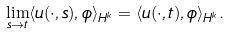Convert formula to latex. <formula><loc_0><loc_0><loc_500><loc_500>\lim _ { s \rightarrow t } \langle u ( \cdot , s ) , \phi \rangle _ { H ^ { k } } = \langle u ( \cdot , t ) , \phi \rangle _ { H ^ { k } } .</formula> 